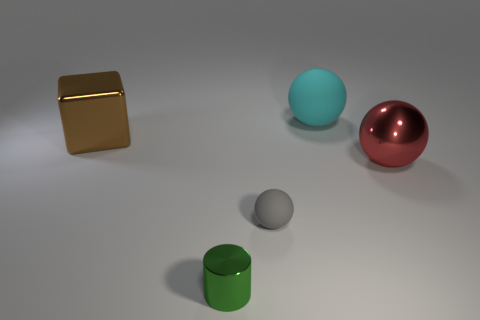There is a thing to the left of the metal thing that is in front of the large thing that is in front of the big brown block; what size is it?
Provide a succinct answer. Large. The thing that is in front of the brown cube and on the left side of the small gray matte thing is what color?
Keep it short and to the point. Green. There is a rubber ball in front of the large red ball; how big is it?
Give a very brief answer. Small. How many objects are made of the same material as the cyan ball?
Offer a terse response. 1. Is the shape of the shiny thing in front of the red metal object the same as  the gray thing?
Ensure brevity in your answer.  No. The other big ball that is the same material as the gray sphere is what color?
Offer a very short reply. Cyan. Are there any small metallic objects that are in front of the matte thing that is in front of the large shiny object to the right of the small rubber sphere?
Your answer should be very brief. Yes. The cyan matte thing has what shape?
Your answer should be compact. Sphere. Is the number of metallic cubes on the right side of the small gray rubber ball less than the number of small brown things?
Ensure brevity in your answer.  No. Are there any other brown objects that have the same shape as the big matte object?
Provide a succinct answer. No. 